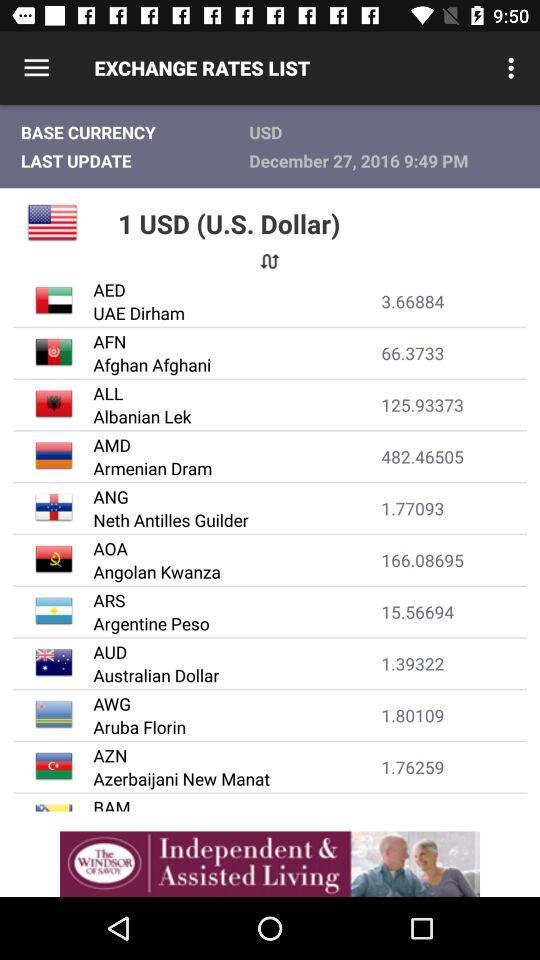What is the exchange rate of the Afghan Afghani to the U.S. Dollar?
Answer the question using a single word or phrase. 66.3733 